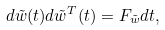Convert formula to latex. <formula><loc_0><loc_0><loc_500><loc_500>d \tilde { w } ( t ) d \tilde { w } ^ { T } ( t ) = F _ { \tilde { w } } d t ,</formula> 